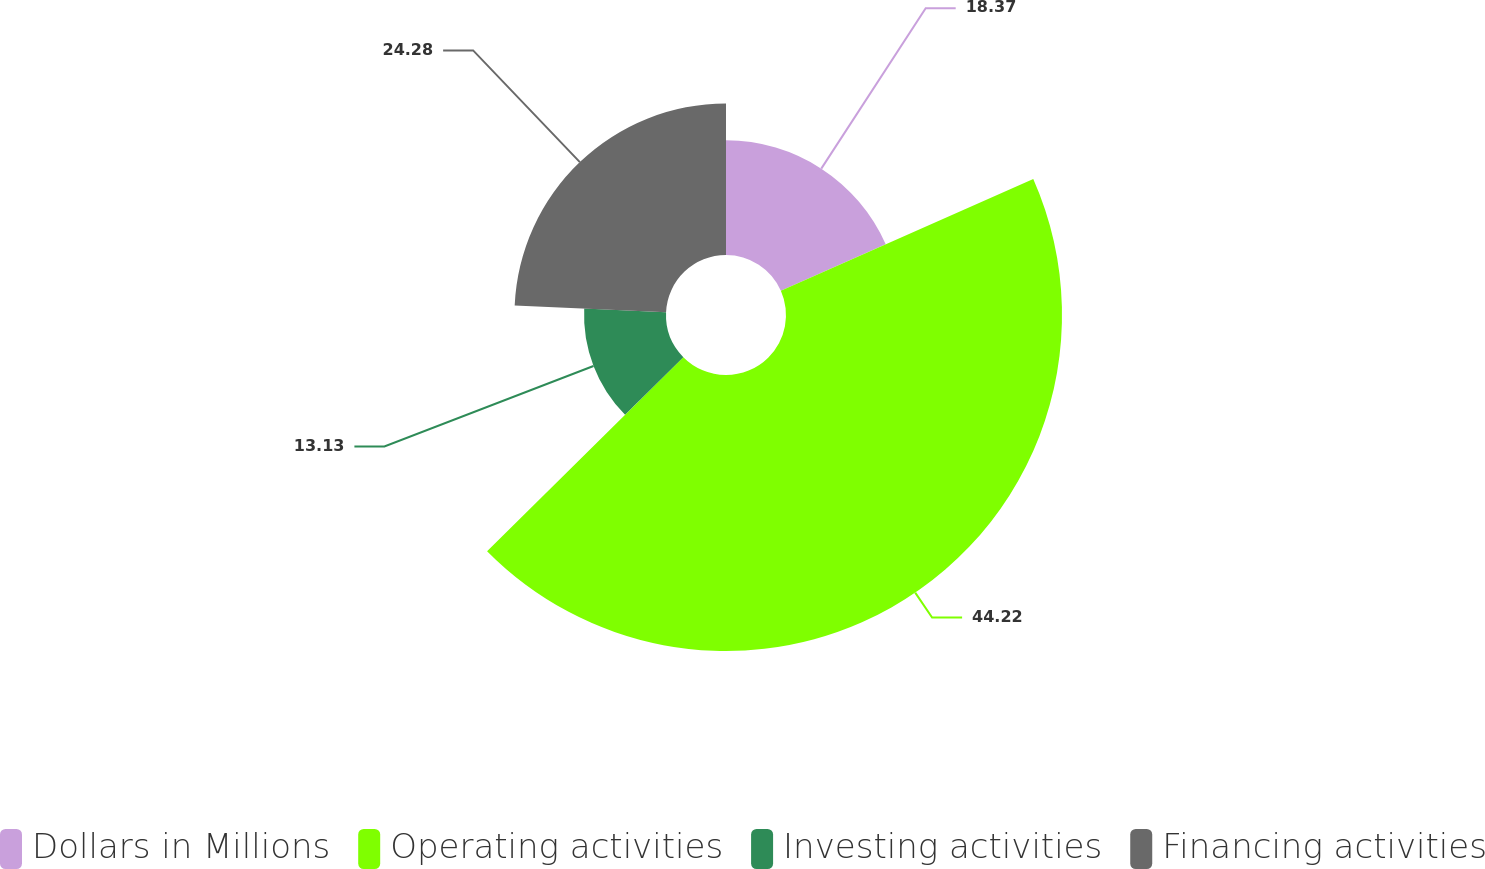Convert chart. <chart><loc_0><loc_0><loc_500><loc_500><pie_chart><fcel>Dollars in Millions<fcel>Operating activities<fcel>Investing activities<fcel>Financing activities<nl><fcel>18.37%<fcel>44.22%<fcel>13.13%<fcel>24.28%<nl></chart> 